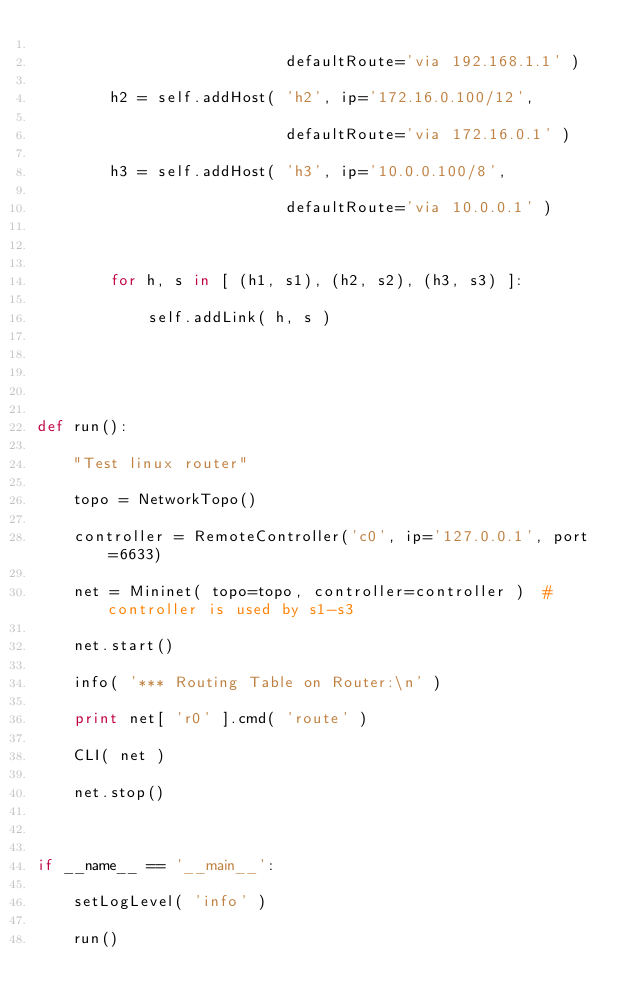Convert code to text. <code><loc_0><loc_0><loc_500><loc_500><_Python_>
                           defaultRoute='via 192.168.1.1' )

        h2 = self.addHost( 'h2', ip='172.16.0.100/12',

                           defaultRoute='via 172.16.0.1' )

        h3 = self.addHost( 'h3', ip='10.0.0.100/8',

                           defaultRoute='via 10.0.0.1' )



        for h, s in [ (h1, s1), (h2, s2), (h3, s3) ]:

            self.addLink( h, s )





def run():

    "Test linux router"

    topo = NetworkTopo()

    controller = RemoteController('c0', ip='127.0.0.1', port=6633)

    net = Mininet( topo=topo, controller=controller )  # controller is used by s1-s3

    net.start()

    info( '*** Routing Table on Router:\n' )

    print net[ 'r0' ].cmd( 'route' )

    CLI( net )

    net.stop()



if __name__ == '__main__':

    setLogLevel( 'info' )

    run()
</code> 